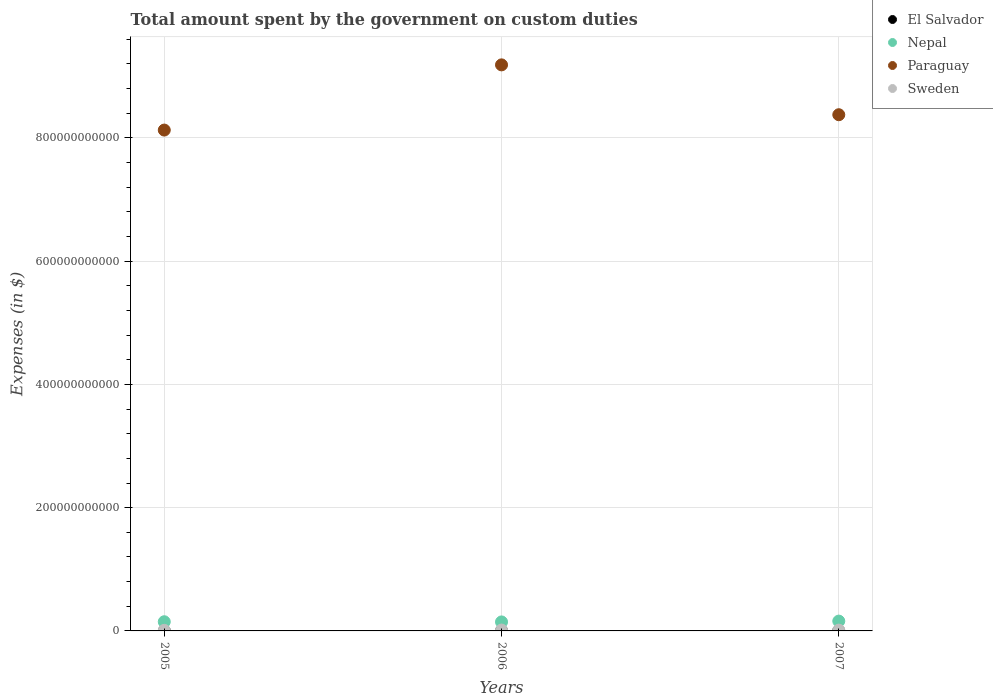What is the amount spent on custom duties by the government in Paraguay in 2005?
Your answer should be very brief. 8.13e+11. Across all years, what is the maximum amount spent on custom duties by the government in El Salvador?
Your response must be concise. 2.04e+08. Across all years, what is the minimum amount spent on custom duties by the government in El Salvador?
Provide a short and direct response. 1.81e+08. In which year was the amount spent on custom duties by the government in Sweden maximum?
Provide a succinct answer. 2006. What is the total amount spent on custom duties by the government in Paraguay in the graph?
Give a very brief answer. 2.57e+12. What is the difference between the amount spent on custom duties by the government in Paraguay in 2005 and that in 2007?
Offer a terse response. -2.49e+1. What is the difference between the amount spent on custom duties by the government in Sweden in 2006 and the amount spent on custom duties by the government in El Salvador in 2005?
Your answer should be very brief. 1.22e+09. What is the average amount spent on custom duties by the government in Nepal per year?
Your answer should be compact. 1.51e+1. In the year 2006, what is the difference between the amount spent on custom duties by the government in Sweden and amount spent on custom duties by the government in Nepal?
Your response must be concise. -1.32e+1. In how many years, is the amount spent on custom duties by the government in El Salvador greater than 720000000000 $?
Make the answer very short. 0. What is the ratio of the amount spent on custom duties by the government in Paraguay in 2005 to that in 2007?
Provide a succinct answer. 0.97. What is the difference between the highest and the second highest amount spent on custom duties by the government in El Salvador?
Keep it short and to the point. 4.10e+06. What is the difference between the highest and the lowest amount spent on custom duties by the government in Sweden?
Ensure brevity in your answer.  4.88e+08. Is the sum of the amount spent on custom duties by the government in Paraguay in 2005 and 2006 greater than the maximum amount spent on custom duties by the government in El Salvador across all years?
Offer a terse response. Yes. Is it the case that in every year, the sum of the amount spent on custom duties by the government in Paraguay and amount spent on custom duties by the government in Sweden  is greater than the amount spent on custom duties by the government in Nepal?
Your answer should be compact. Yes. Is the amount spent on custom duties by the government in Paraguay strictly greater than the amount spent on custom duties by the government in Sweden over the years?
Give a very brief answer. Yes. Is the amount spent on custom duties by the government in Paraguay strictly less than the amount spent on custom duties by the government in Nepal over the years?
Your response must be concise. No. How many dotlines are there?
Provide a short and direct response. 4. How many years are there in the graph?
Keep it short and to the point. 3. What is the difference between two consecutive major ticks on the Y-axis?
Your answer should be very brief. 2.00e+11. Does the graph contain grids?
Your response must be concise. Yes. Where does the legend appear in the graph?
Your answer should be very brief. Top right. What is the title of the graph?
Your answer should be very brief. Total amount spent by the government on custom duties. Does "Libya" appear as one of the legend labels in the graph?
Provide a succinct answer. No. What is the label or title of the Y-axis?
Your response must be concise. Expenses (in $). What is the Expenses (in $) in El Salvador in 2005?
Give a very brief answer. 1.81e+08. What is the Expenses (in $) in Nepal in 2005?
Give a very brief answer. 1.49e+1. What is the Expenses (in $) in Paraguay in 2005?
Your response must be concise. 8.13e+11. What is the Expenses (in $) in Sweden in 2005?
Give a very brief answer. 9.12e+08. What is the Expenses (in $) in El Salvador in 2006?
Ensure brevity in your answer.  2.00e+08. What is the Expenses (in $) in Nepal in 2006?
Provide a short and direct response. 1.46e+1. What is the Expenses (in $) of Paraguay in 2006?
Ensure brevity in your answer.  9.18e+11. What is the Expenses (in $) in Sweden in 2006?
Give a very brief answer. 1.40e+09. What is the Expenses (in $) in El Salvador in 2007?
Offer a terse response. 2.04e+08. What is the Expenses (in $) of Nepal in 2007?
Ensure brevity in your answer.  1.59e+1. What is the Expenses (in $) of Paraguay in 2007?
Offer a terse response. 8.38e+11. What is the Expenses (in $) in Sweden in 2007?
Your answer should be compact. 1.28e+09. Across all years, what is the maximum Expenses (in $) in El Salvador?
Offer a terse response. 2.04e+08. Across all years, what is the maximum Expenses (in $) in Nepal?
Keep it short and to the point. 1.59e+1. Across all years, what is the maximum Expenses (in $) in Paraguay?
Your response must be concise. 9.18e+11. Across all years, what is the maximum Expenses (in $) of Sweden?
Offer a terse response. 1.40e+09. Across all years, what is the minimum Expenses (in $) of El Salvador?
Provide a succinct answer. 1.81e+08. Across all years, what is the minimum Expenses (in $) in Nepal?
Provide a succinct answer. 1.46e+1. Across all years, what is the minimum Expenses (in $) of Paraguay?
Give a very brief answer. 8.13e+11. Across all years, what is the minimum Expenses (in $) of Sweden?
Your answer should be compact. 9.12e+08. What is the total Expenses (in $) of El Salvador in the graph?
Your answer should be very brief. 5.84e+08. What is the total Expenses (in $) of Nepal in the graph?
Your response must be concise. 4.54e+1. What is the total Expenses (in $) in Paraguay in the graph?
Offer a terse response. 2.57e+12. What is the total Expenses (in $) of Sweden in the graph?
Provide a succinct answer. 3.59e+09. What is the difference between the Expenses (in $) in El Salvador in 2005 and that in 2006?
Give a very brief answer. -1.88e+07. What is the difference between the Expenses (in $) in Nepal in 2005 and that in 2006?
Offer a very short reply. 2.91e+08. What is the difference between the Expenses (in $) in Paraguay in 2005 and that in 2006?
Ensure brevity in your answer.  -1.06e+11. What is the difference between the Expenses (in $) in Sweden in 2005 and that in 2006?
Offer a terse response. -4.88e+08. What is the difference between the Expenses (in $) in El Salvador in 2005 and that in 2007?
Offer a very short reply. -2.29e+07. What is the difference between the Expenses (in $) in Nepal in 2005 and that in 2007?
Your answer should be very brief. -1.04e+09. What is the difference between the Expenses (in $) of Paraguay in 2005 and that in 2007?
Offer a terse response. -2.49e+1. What is the difference between the Expenses (in $) of Sweden in 2005 and that in 2007?
Offer a terse response. -3.68e+08. What is the difference between the Expenses (in $) of El Salvador in 2006 and that in 2007?
Keep it short and to the point. -4.10e+06. What is the difference between the Expenses (in $) of Nepal in 2006 and that in 2007?
Your answer should be compact. -1.33e+09. What is the difference between the Expenses (in $) of Paraguay in 2006 and that in 2007?
Give a very brief answer. 8.09e+1. What is the difference between the Expenses (in $) in Sweden in 2006 and that in 2007?
Your answer should be very brief. 1.20e+08. What is the difference between the Expenses (in $) in El Salvador in 2005 and the Expenses (in $) in Nepal in 2006?
Keep it short and to the point. -1.44e+1. What is the difference between the Expenses (in $) of El Salvador in 2005 and the Expenses (in $) of Paraguay in 2006?
Give a very brief answer. -9.18e+11. What is the difference between the Expenses (in $) of El Salvador in 2005 and the Expenses (in $) of Sweden in 2006?
Your answer should be very brief. -1.22e+09. What is the difference between the Expenses (in $) in Nepal in 2005 and the Expenses (in $) in Paraguay in 2006?
Make the answer very short. -9.04e+11. What is the difference between the Expenses (in $) of Nepal in 2005 and the Expenses (in $) of Sweden in 2006?
Give a very brief answer. 1.35e+1. What is the difference between the Expenses (in $) of Paraguay in 2005 and the Expenses (in $) of Sweden in 2006?
Make the answer very short. 8.11e+11. What is the difference between the Expenses (in $) in El Salvador in 2005 and the Expenses (in $) in Nepal in 2007?
Ensure brevity in your answer.  -1.57e+1. What is the difference between the Expenses (in $) of El Salvador in 2005 and the Expenses (in $) of Paraguay in 2007?
Offer a very short reply. -8.37e+11. What is the difference between the Expenses (in $) of El Salvador in 2005 and the Expenses (in $) of Sweden in 2007?
Provide a short and direct response. -1.10e+09. What is the difference between the Expenses (in $) of Nepal in 2005 and the Expenses (in $) of Paraguay in 2007?
Provide a short and direct response. -8.23e+11. What is the difference between the Expenses (in $) of Nepal in 2005 and the Expenses (in $) of Sweden in 2007?
Provide a succinct answer. 1.36e+1. What is the difference between the Expenses (in $) in Paraguay in 2005 and the Expenses (in $) in Sweden in 2007?
Offer a terse response. 8.11e+11. What is the difference between the Expenses (in $) in El Salvador in 2006 and the Expenses (in $) in Nepal in 2007?
Give a very brief answer. -1.57e+1. What is the difference between the Expenses (in $) in El Salvador in 2006 and the Expenses (in $) in Paraguay in 2007?
Offer a terse response. -8.37e+11. What is the difference between the Expenses (in $) of El Salvador in 2006 and the Expenses (in $) of Sweden in 2007?
Ensure brevity in your answer.  -1.08e+09. What is the difference between the Expenses (in $) of Nepal in 2006 and the Expenses (in $) of Paraguay in 2007?
Offer a very short reply. -8.23e+11. What is the difference between the Expenses (in $) of Nepal in 2006 and the Expenses (in $) of Sweden in 2007?
Your answer should be very brief. 1.33e+1. What is the difference between the Expenses (in $) in Paraguay in 2006 and the Expenses (in $) in Sweden in 2007?
Offer a very short reply. 9.17e+11. What is the average Expenses (in $) of El Salvador per year?
Your answer should be compact. 1.95e+08. What is the average Expenses (in $) in Nepal per year?
Make the answer very short. 1.51e+1. What is the average Expenses (in $) of Paraguay per year?
Offer a terse response. 8.56e+11. What is the average Expenses (in $) of Sweden per year?
Make the answer very short. 1.20e+09. In the year 2005, what is the difference between the Expenses (in $) of El Salvador and Expenses (in $) of Nepal?
Your response must be concise. -1.47e+1. In the year 2005, what is the difference between the Expenses (in $) in El Salvador and Expenses (in $) in Paraguay?
Your response must be concise. -8.13e+11. In the year 2005, what is the difference between the Expenses (in $) in El Salvador and Expenses (in $) in Sweden?
Provide a succinct answer. -7.31e+08. In the year 2005, what is the difference between the Expenses (in $) of Nepal and Expenses (in $) of Paraguay?
Provide a succinct answer. -7.98e+11. In the year 2005, what is the difference between the Expenses (in $) of Nepal and Expenses (in $) of Sweden?
Your answer should be very brief. 1.40e+1. In the year 2005, what is the difference between the Expenses (in $) of Paraguay and Expenses (in $) of Sweden?
Make the answer very short. 8.12e+11. In the year 2006, what is the difference between the Expenses (in $) in El Salvador and Expenses (in $) in Nepal?
Your response must be concise. -1.44e+1. In the year 2006, what is the difference between the Expenses (in $) of El Salvador and Expenses (in $) of Paraguay?
Your answer should be very brief. -9.18e+11. In the year 2006, what is the difference between the Expenses (in $) in El Salvador and Expenses (in $) in Sweden?
Make the answer very short. -1.20e+09. In the year 2006, what is the difference between the Expenses (in $) in Nepal and Expenses (in $) in Paraguay?
Make the answer very short. -9.04e+11. In the year 2006, what is the difference between the Expenses (in $) in Nepal and Expenses (in $) in Sweden?
Ensure brevity in your answer.  1.32e+1. In the year 2006, what is the difference between the Expenses (in $) in Paraguay and Expenses (in $) in Sweden?
Provide a succinct answer. 9.17e+11. In the year 2007, what is the difference between the Expenses (in $) in El Salvador and Expenses (in $) in Nepal?
Your response must be concise. -1.57e+1. In the year 2007, what is the difference between the Expenses (in $) of El Salvador and Expenses (in $) of Paraguay?
Your answer should be very brief. -8.37e+11. In the year 2007, what is the difference between the Expenses (in $) of El Salvador and Expenses (in $) of Sweden?
Your response must be concise. -1.08e+09. In the year 2007, what is the difference between the Expenses (in $) of Nepal and Expenses (in $) of Paraguay?
Your answer should be very brief. -8.22e+11. In the year 2007, what is the difference between the Expenses (in $) of Nepal and Expenses (in $) of Sweden?
Provide a short and direct response. 1.46e+1. In the year 2007, what is the difference between the Expenses (in $) in Paraguay and Expenses (in $) in Sweden?
Provide a short and direct response. 8.36e+11. What is the ratio of the Expenses (in $) in El Salvador in 2005 to that in 2006?
Give a very brief answer. 0.91. What is the ratio of the Expenses (in $) of Nepal in 2005 to that in 2006?
Provide a short and direct response. 1.02. What is the ratio of the Expenses (in $) of Paraguay in 2005 to that in 2006?
Offer a terse response. 0.88. What is the ratio of the Expenses (in $) of Sweden in 2005 to that in 2006?
Your answer should be compact. 0.65. What is the ratio of the Expenses (in $) of El Salvador in 2005 to that in 2007?
Make the answer very short. 0.89. What is the ratio of the Expenses (in $) in Nepal in 2005 to that in 2007?
Ensure brevity in your answer.  0.93. What is the ratio of the Expenses (in $) of Paraguay in 2005 to that in 2007?
Give a very brief answer. 0.97. What is the ratio of the Expenses (in $) in Sweden in 2005 to that in 2007?
Provide a succinct answer. 0.71. What is the ratio of the Expenses (in $) of El Salvador in 2006 to that in 2007?
Keep it short and to the point. 0.98. What is the ratio of the Expenses (in $) in Nepal in 2006 to that in 2007?
Your answer should be very brief. 0.92. What is the ratio of the Expenses (in $) of Paraguay in 2006 to that in 2007?
Keep it short and to the point. 1.1. What is the ratio of the Expenses (in $) in Sweden in 2006 to that in 2007?
Keep it short and to the point. 1.09. What is the difference between the highest and the second highest Expenses (in $) of El Salvador?
Offer a very short reply. 4.10e+06. What is the difference between the highest and the second highest Expenses (in $) in Nepal?
Your response must be concise. 1.04e+09. What is the difference between the highest and the second highest Expenses (in $) in Paraguay?
Give a very brief answer. 8.09e+1. What is the difference between the highest and the second highest Expenses (in $) of Sweden?
Your response must be concise. 1.20e+08. What is the difference between the highest and the lowest Expenses (in $) of El Salvador?
Give a very brief answer. 2.29e+07. What is the difference between the highest and the lowest Expenses (in $) of Nepal?
Provide a short and direct response. 1.33e+09. What is the difference between the highest and the lowest Expenses (in $) in Paraguay?
Give a very brief answer. 1.06e+11. What is the difference between the highest and the lowest Expenses (in $) in Sweden?
Your response must be concise. 4.88e+08. 